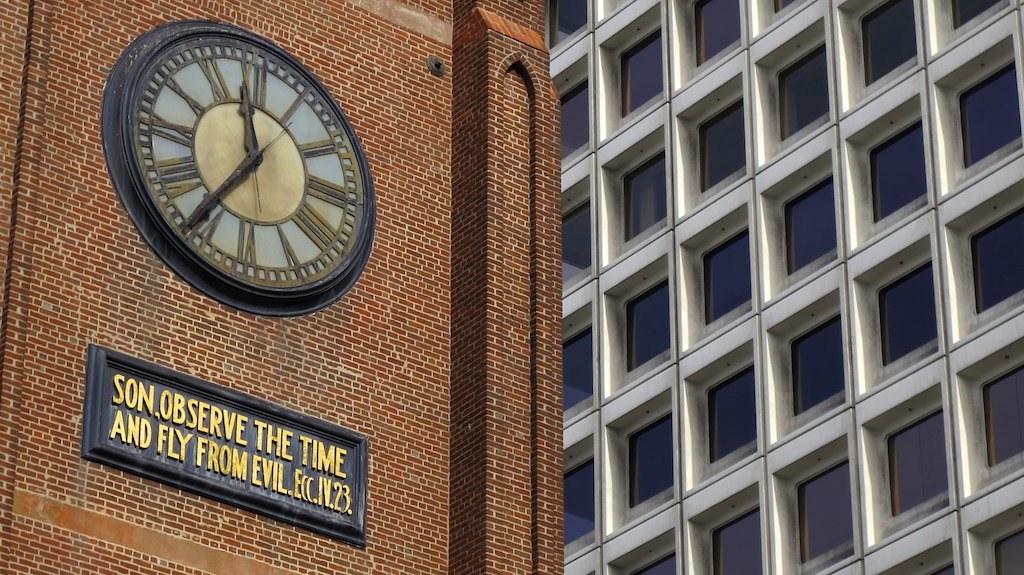What does the sign below the clock say?
Give a very brief answer. Son observe the time and fly from evil. What time is on the clock?
Provide a short and direct response. 11:36. 